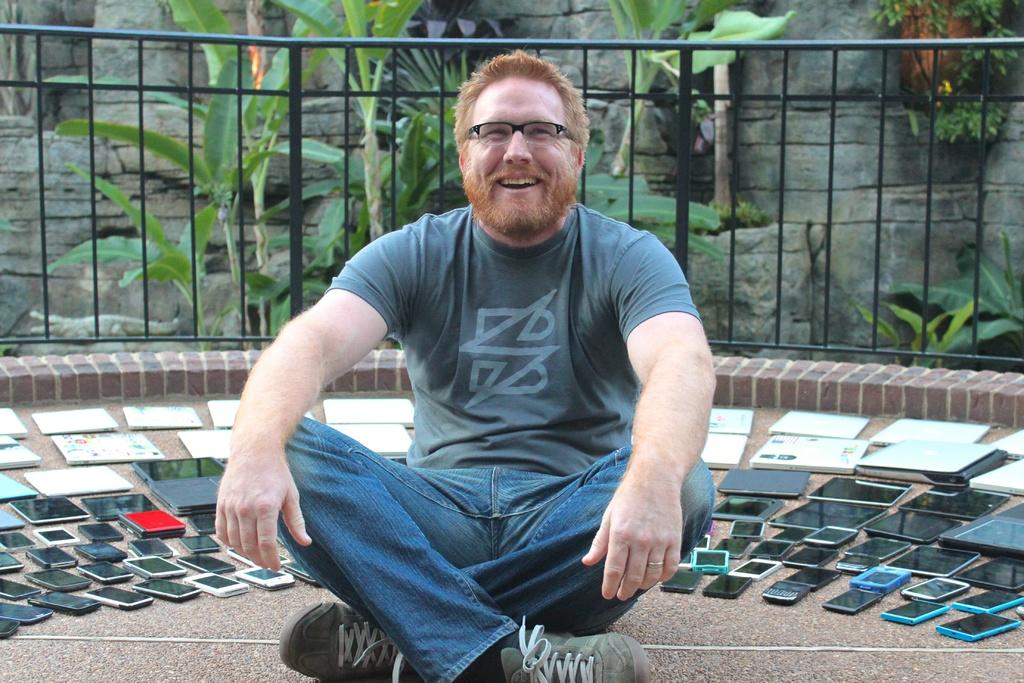What is the main subject in the middle of the image? There is a man in the middle of the image. What type of electronic devices can be seen in the image? Mobile phones, laptops, and other electronic devices are visible in the image. What can be seen in the background of the image? There are trees and an iron grill in the background of the image. How many horses are present in the image? There are no horses present in the image. What type of humor can be seen in the image? There is no humor depicted in the image. 